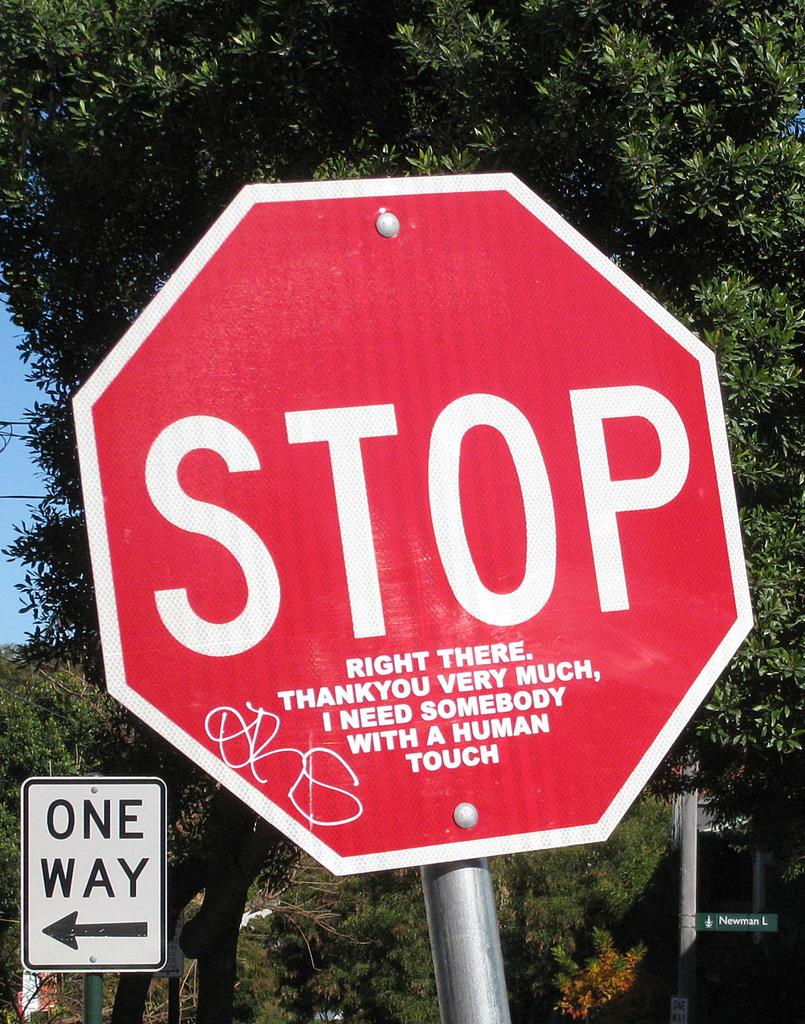What is the main object on the right side of the image? There is a red color board fixed to a pole in the image. What is the color and location of the other board in the image? There is a white color board on the left side of the image. What can be seen in the background of the image? There are trees and the sky visible in the background of the image. How many astronauts can be seen in the image? There are no astronauts present in the image. What type of net is used to catch the birds in the image? There is no net or birds present in the image. 